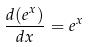<formula> <loc_0><loc_0><loc_500><loc_500>\frac { d ( e ^ { x } ) } { d x } = e ^ { x }</formula> 